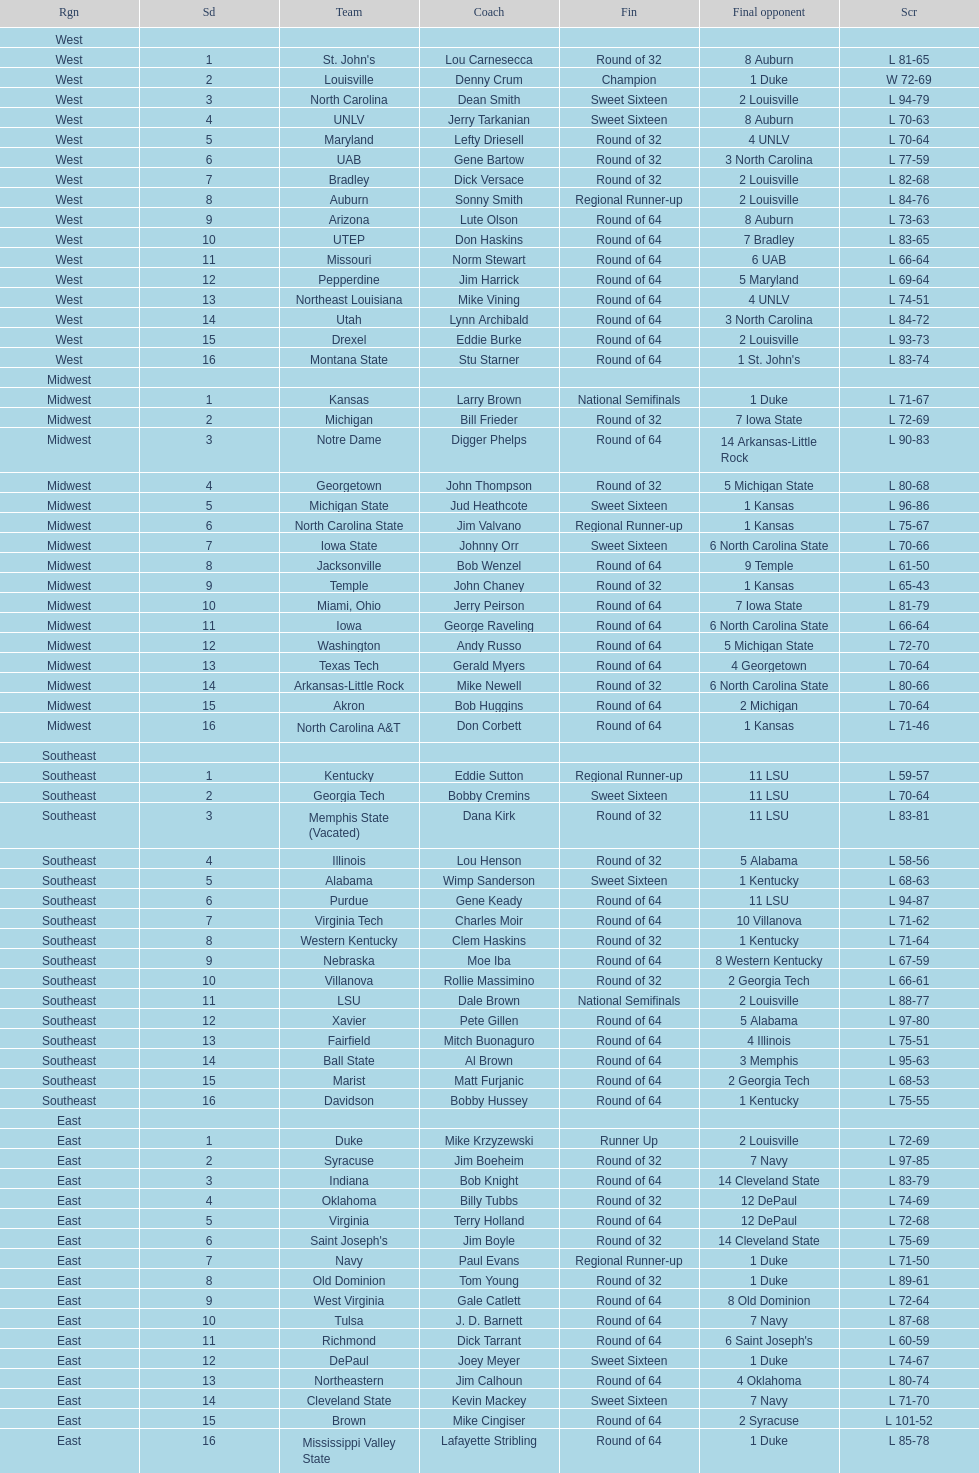What region is listed before the midwest? West. 